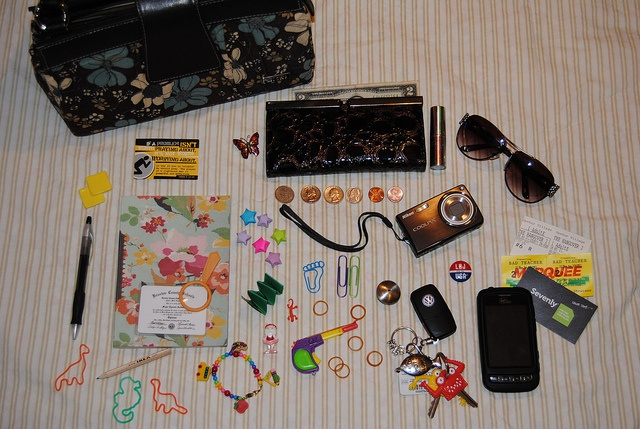Describe the objects in this image and their specific colors. I can see handbag in gray, black, and purple tones, book in gray, darkgray, and brown tones, and cell phone in gray, black, and darkgray tones in this image. 